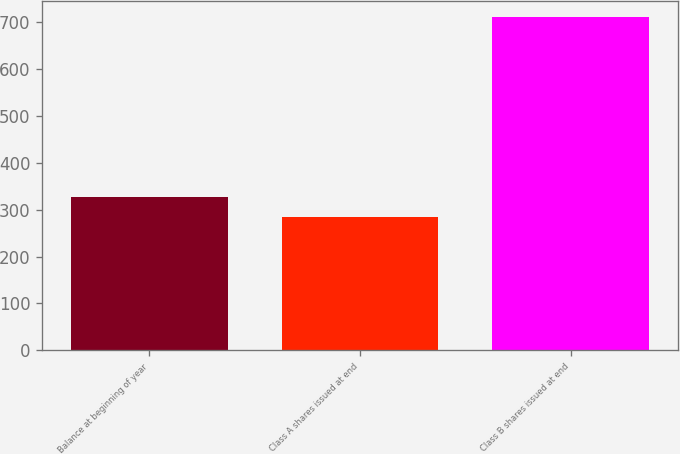Convert chart to OTSL. <chart><loc_0><loc_0><loc_500><loc_500><bar_chart><fcel>Balance at beginning of year<fcel>Class A shares issued at end<fcel>Class B shares issued at end<nl><fcel>327.6<fcel>285<fcel>711<nl></chart> 